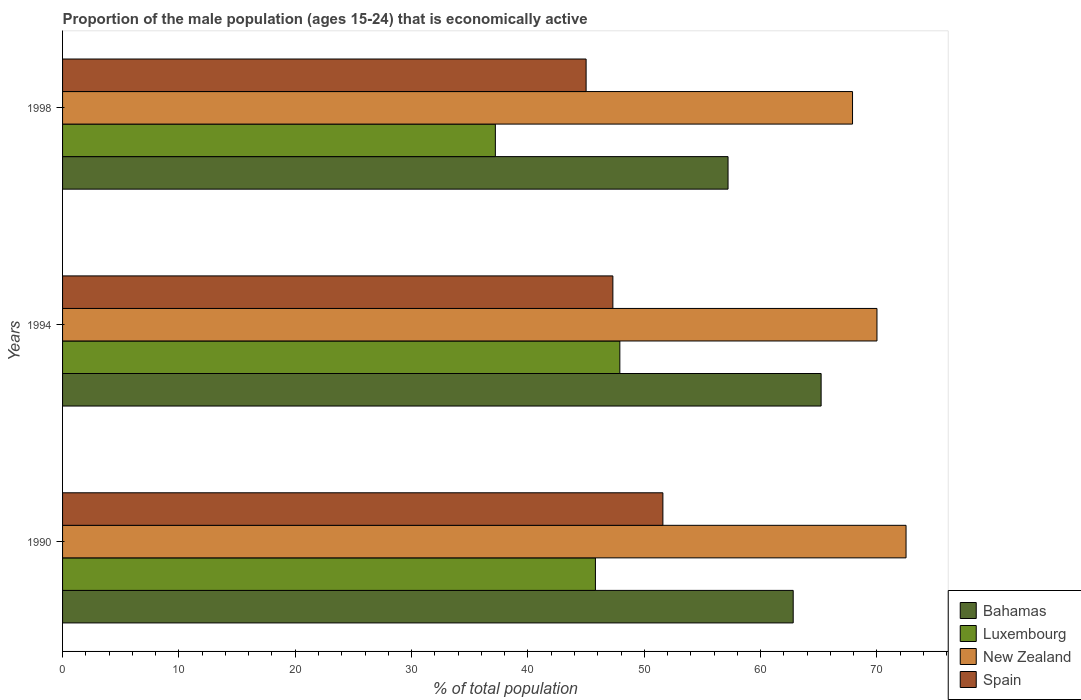How many groups of bars are there?
Keep it short and to the point. 3. How many bars are there on the 2nd tick from the top?
Give a very brief answer. 4. What is the label of the 2nd group of bars from the top?
Provide a short and direct response. 1994. In how many cases, is the number of bars for a given year not equal to the number of legend labels?
Keep it short and to the point. 0. What is the proportion of the male population that is economically active in Luxembourg in 1990?
Give a very brief answer. 45.8. Across all years, what is the maximum proportion of the male population that is economically active in Bahamas?
Your response must be concise. 65.2. Across all years, what is the minimum proportion of the male population that is economically active in New Zealand?
Keep it short and to the point. 67.9. What is the total proportion of the male population that is economically active in Bahamas in the graph?
Offer a very short reply. 185.2. What is the difference between the proportion of the male population that is economically active in New Zealand in 1990 and that in 1994?
Offer a very short reply. 2.5. What is the difference between the proportion of the male population that is economically active in Spain in 1994 and the proportion of the male population that is economically active in Bahamas in 1998?
Your answer should be very brief. -9.9. What is the average proportion of the male population that is economically active in Luxembourg per year?
Give a very brief answer. 43.63. What is the ratio of the proportion of the male population that is economically active in Spain in 1994 to that in 1998?
Provide a succinct answer. 1.05. Is the proportion of the male population that is economically active in Luxembourg in 1990 less than that in 1994?
Provide a short and direct response. Yes. What is the difference between the highest and the second highest proportion of the male population that is economically active in Spain?
Your answer should be very brief. 4.3. What is the difference between the highest and the lowest proportion of the male population that is economically active in New Zealand?
Provide a succinct answer. 4.6. In how many years, is the proportion of the male population that is economically active in Luxembourg greater than the average proportion of the male population that is economically active in Luxembourg taken over all years?
Make the answer very short. 2. Is the sum of the proportion of the male population that is economically active in Bahamas in 1994 and 1998 greater than the maximum proportion of the male population that is economically active in Luxembourg across all years?
Your response must be concise. Yes. Is it the case that in every year, the sum of the proportion of the male population that is economically active in Luxembourg and proportion of the male population that is economically active in Bahamas is greater than the sum of proportion of the male population that is economically active in New Zealand and proportion of the male population that is economically active in Spain?
Make the answer very short. Yes. What does the 3rd bar from the top in 1990 represents?
Offer a very short reply. Luxembourg. What does the 1st bar from the bottom in 1998 represents?
Your answer should be compact. Bahamas. How many bars are there?
Offer a very short reply. 12. How many years are there in the graph?
Offer a very short reply. 3. Are the values on the major ticks of X-axis written in scientific E-notation?
Your answer should be very brief. No. Does the graph contain any zero values?
Offer a very short reply. No. Does the graph contain grids?
Your answer should be compact. No. What is the title of the graph?
Offer a very short reply. Proportion of the male population (ages 15-24) that is economically active. What is the label or title of the X-axis?
Ensure brevity in your answer.  % of total population. What is the % of total population of Bahamas in 1990?
Ensure brevity in your answer.  62.8. What is the % of total population of Luxembourg in 1990?
Ensure brevity in your answer.  45.8. What is the % of total population in New Zealand in 1990?
Ensure brevity in your answer.  72.5. What is the % of total population in Spain in 1990?
Make the answer very short. 51.6. What is the % of total population of Bahamas in 1994?
Give a very brief answer. 65.2. What is the % of total population in Luxembourg in 1994?
Offer a very short reply. 47.9. What is the % of total population in New Zealand in 1994?
Provide a succinct answer. 70. What is the % of total population in Spain in 1994?
Make the answer very short. 47.3. What is the % of total population of Bahamas in 1998?
Give a very brief answer. 57.2. What is the % of total population of Luxembourg in 1998?
Provide a succinct answer. 37.2. What is the % of total population in New Zealand in 1998?
Offer a very short reply. 67.9. Across all years, what is the maximum % of total population of Bahamas?
Ensure brevity in your answer.  65.2. Across all years, what is the maximum % of total population in Luxembourg?
Provide a succinct answer. 47.9. Across all years, what is the maximum % of total population of New Zealand?
Keep it short and to the point. 72.5. Across all years, what is the maximum % of total population in Spain?
Provide a succinct answer. 51.6. Across all years, what is the minimum % of total population of Bahamas?
Your answer should be compact. 57.2. Across all years, what is the minimum % of total population in Luxembourg?
Provide a succinct answer. 37.2. Across all years, what is the minimum % of total population in New Zealand?
Your answer should be very brief. 67.9. Across all years, what is the minimum % of total population of Spain?
Make the answer very short. 45. What is the total % of total population in Bahamas in the graph?
Ensure brevity in your answer.  185.2. What is the total % of total population in Luxembourg in the graph?
Offer a terse response. 130.9. What is the total % of total population in New Zealand in the graph?
Your answer should be very brief. 210.4. What is the total % of total population of Spain in the graph?
Provide a short and direct response. 143.9. What is the difference between the % of total population in Luxembourg in 1990 and that in 1994?
Your answer should be compact. -2.1. What is the difference between the % of total population in Spain in 1990 and that in 1994?
Keep it short and to the point. 4.3. What is the difference between the % of total population in New Zealand in 1990 and that in 1998?
Your response must be concise. 4.6. What is the difference between the % of total population in Spain in 1990 and that in 1998?
Offer a very short reply. 6.6. What is the difference between the % of total population in New Zealand in 1994 and that in 1998?
Your answer should be compact. 2.1. What is the difference between the % of total population of Spain in 1994 and that in 1998?
Provide a short and direct response. 2.3. What is the difference between the % of total population of Bahamas in 1990 and the % of total population of New Zealand in 1994?
Offer a very short reply. -7.2. What is the difference between the % of total population of Bahamas in 1990 and the % of total population of Spain in 1994?
Ensure brevity in your answer.  15.5. What is the difference between the % of total population of Luxembourg in 1990 and the % of total population of New Zealand in 1994?
Your answer should be compact. -24.2. What is the difference between the % of total population in Luxembourg in 1990 and the % of total population in Spain in 1994?
Your answer should be compact. -1.5. What is the difference between the % of total population of New Zealand in 1990 and the % of total population of Spain in 1994?
Provide a succinct answer. 25.2. What is the difference between the % of total population of Bahamas in 1990 and the % of total population of Luxembourg in 1998?
Provide a short and direct response. 25.6. What is the difference between the % of total population of Luxembourg in 1990 and the % of total population of New Zealand in 1998?
Your answer should be very brief. -22.1. What is the difference between the % of total population of Bahamas in 1994 and the % of total population of New Zealand in 1998?
Give a very brief answer. -2.7. What is the difference between the % of total population in Bahamas in 1994 and the % of total population in Spain in 1998?
Ensure brevity in your answer.  20.2. What is the difference between the % of total population in Luxembourg in 1994 and the % of total population in Spain in 1998?
Offer a terse response. 2.9. What is the average % of total population in Bahamas per year?
Make the answer very short. 61.73. What is the average % of total population of Luxembourg per year?
Offer a terse response. 43.63. What is the average % of total population in New Zealand per year?
Give a very brief answer. 70.13. What is the average % of total population of Spain per year?
Your answer should be very brief. 47.97. In the year 1990, what is the difference between the % of total population in Bahamas and % of total population in Luxembourg?
Offer a terse response. 17. In the year 1990, what is the difference between the % of total population in Bahamas and % of total population in New Zealand?
Provide a short and direct response. -9.7. In the year 1990, what is the difference between the % of total population in Bahamas and % of total population in Spain?
Provide a short and direct response. 11.2. In the year 1990, what is the difference between the % of total population in Luxembourg and % of total population in New Zealand?
Provide a succinct answer. -26.7. In the year 1990, what is the difference between the % of total population in New Zealand and % of total population in Spain?
Your response must be concise. 20.9. In the year 1994, what is the difference between the % of total population in Bahamas and % of total population in New Zealand?
Keep it short and to the point. -4.8. In the year 1994, what is the difference between the % of total population in Luxembourg and % of total population in New Zealand?
Give a very brief answer. -22.1. In the year 1994, what is the difference between the % of total population of Luxembourg and % of total population of Spain?
Your response must be concise. 0.6. In the year 1994, what is the difference between the % of total population of New Zealand and % of total population of Spain?
Ensure brevity in your answer.  22.7. In the year 1998, what is the difference between the % of total population in Luxembourg and % of total population in New Zealand?
Keep it short and to the point. -30.7. In the year 1998, what is the difference between the % of total population in New Zealand and % of total population in Spain?
Offer a very short reply. 22.9. What is the ratio of the % of total population of Bahamas in 1990 to that in 1994?
Ensure brevity in your answer.  0.96. What is the ratio of the % of total population of Luxembourg in 1990 to that in 1994?
Keep it short and to the point. 0.96. What is the ratio of the % of total population in New Zealand in 1990 to that in 1994?
Make the answer very short. 1.04. What is the ratio of the % of total population of Bahamas in 1990 to that in 1998?
Your answer should be compact. 1.1. What is the ratio of the % of total population in Luxembourg in 1990 to that in 1998?
Offer a terse response. 1.23. What is the ratio of the % of total population in New Zealand in 1990 to that in 1998?
Your answer should be very brief. 1.07. What is the ratio of the % of total population in Spain in 1990 to that in 1998?
Your response must be concise. 1.15. What is the ratio of the % of total population of Bahamas in 1994 to that in 1998?
Offer a very short reply. 1.14. What is the ratio of the % of total population of Luxembourg in 1994 to that in 1998?
Give a very brief answer. 1.29. What is the ratio of the % of total population in New Zealand in 1994 to that in 1998?
Offer a terse response. 1.03. What is the ratio of the % of total population of Spain in 1994 to that in 1998?
Ensure brevity in your answer.  1.05. What is the difference between the highest and the second highest % of total population in Bahamas?
Keep it short and to the point. 2.4. What is the difference between the highest and the second highest % of total population in New Zealand?
Provide a short and direct response. 2.5. What is the difference between the highest and the second highest % of total population in Spain?
Keep it short and to the point. 4.3. What is the difference between the highest and the lowest % of total population of Bahamas?
Ensure brevity in your answer.  8. What is the difference between the highest and the lowest % of total population of New Zealand?
Make the answer very short. 4.6. 